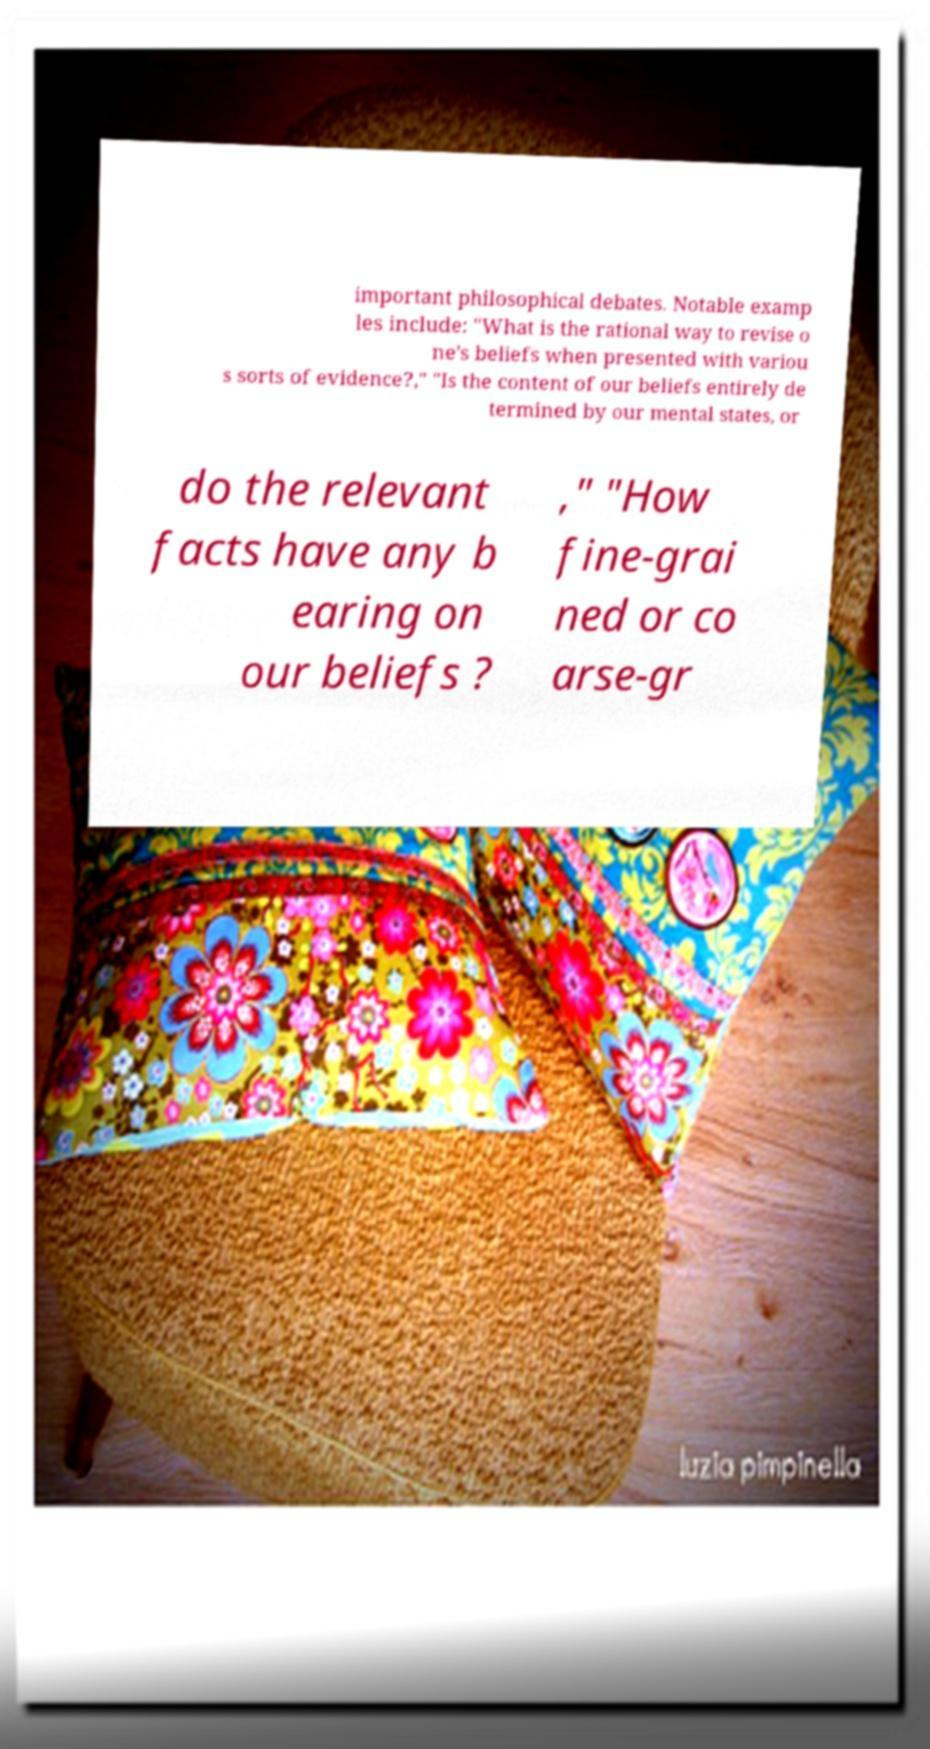Please identify and transcribe the text found in this image. important philosophical debates. Notable examp les include: "What is the rational way to revise o ne's beliefs when presented with variou s sorts of evidence?," "Is the content of our beliefs entirely de termined by our mental states, or do the relevant facts have any b earing on our beliefs ? ," "How fine-grai ned or co arse-gr 